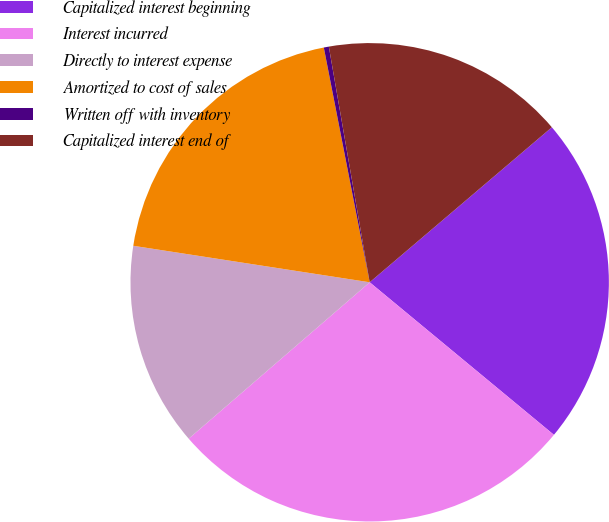Convert chart to OTSL. <chart><loc_0><loc_0><loc_500><loc_500><pie_chart><fcel>Capitalized interest beginning<fcel>Interest incurred<fcel>Directly to interest expense<fcel>Amortized to cost of sales<fcel>Written off with inventory<fcel>Capitalized interest end of<nl><fcel>22.23%<fcel>27.65%<fcel>13.78%<fcel>19.49%<fcel>0.34%<fcel>16.51%<nl></chart> 